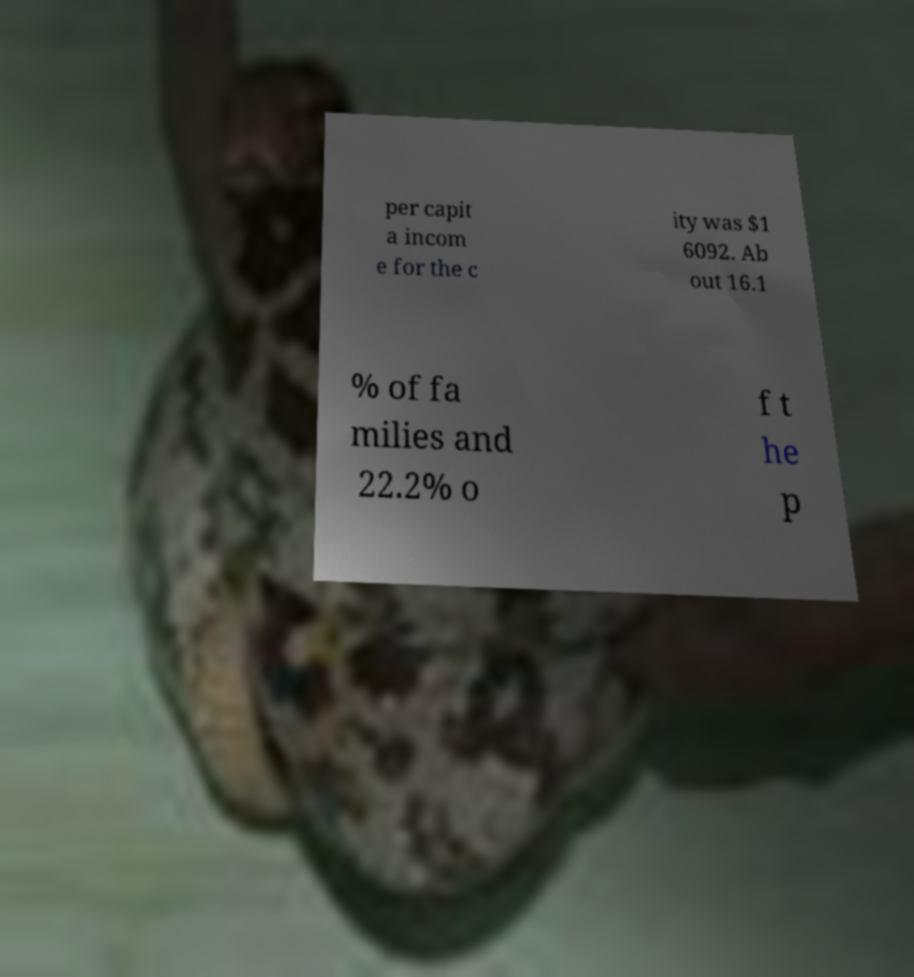Could you assist in decoding the text presented in this image and type it out clearly? per capit a incom e for the c ity was $1 6092. Ab out 16.1 % of fa milies and 22.2% o f t he p 